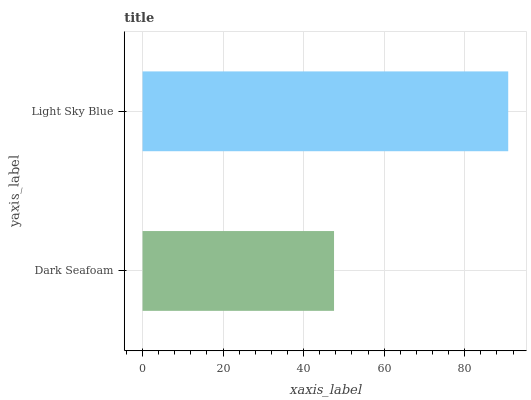Is Dark Seafoam the minimum?
Answer yes or no. Yes. Is Light Sky Blue the maximum?
Answer yes or no. Yes. Is Light Sky Blue the minimum?
Answer yes or no. No. Is Light Sky Blue greater than Dark Seafoam?
Answer yes or no. Yes. Is Dark Seafoam less than Light Sky Blue?
Answer yes or no. Yes. Is Dark Seafoam greater than Light Sky Blue?
Answer yes or no. No. Is Light Sky Blue less than Dark Seafoam?
Answer yes or no. No. Is Light Sky Blue the high median?
Answer yes or no. Yes. Is Dark Seafoam the low median?
Answer yes or no. Yes. Is Dark Seafoam the high median?
Answer yes or no. No. Is Light Sky Blue the low median?
Answer yes or no. No. 